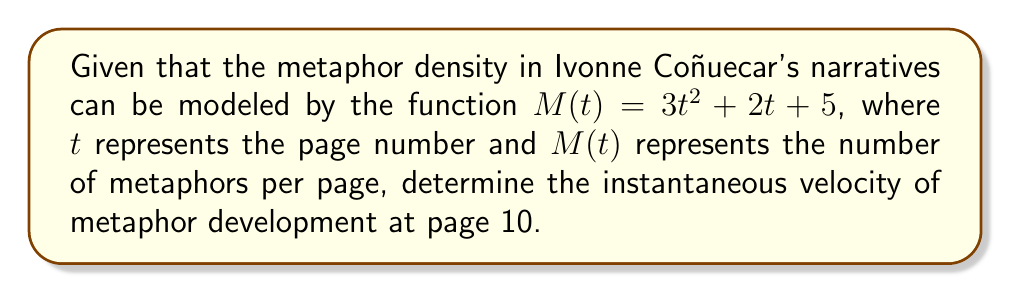Can you answer this question? To find the instantaneous velocity of metaphor development, we need to calculate the derivative of the given function $M(t)$ and evaluate it at $t = 10$. Let's follow these steps:

1) The given function is $M(t) = 3t^2 + 2t + 5$

2) To find the derivative, we apply the power rule and the constant rule:
   $$\frac{d}{dt}M(t) = \frac{d}{dt}(3t^2) + \frac{d}{dt}(2t) + \frac{d}{dt}(5)$$
   $$M'(t) = 6t + 2 + 0$$
   $$M'(t) = 6t + 2$$

3) The derivative $M'(t)$ represents the instantaneous velocity of metaphor development at any given page $t$.

4) To find the instantaneous velocity at page 10, we substitute $t = 10$ into $M'(t)$:
   $$M'(10) = 6(10) + 2$$
   $$M'(10) = 60 + 2 = 62$$

Therefore, the instantaneous velocity of metaphor development at page 10 is 62 metaphors per page.
Answer: 62 metaphors/page 